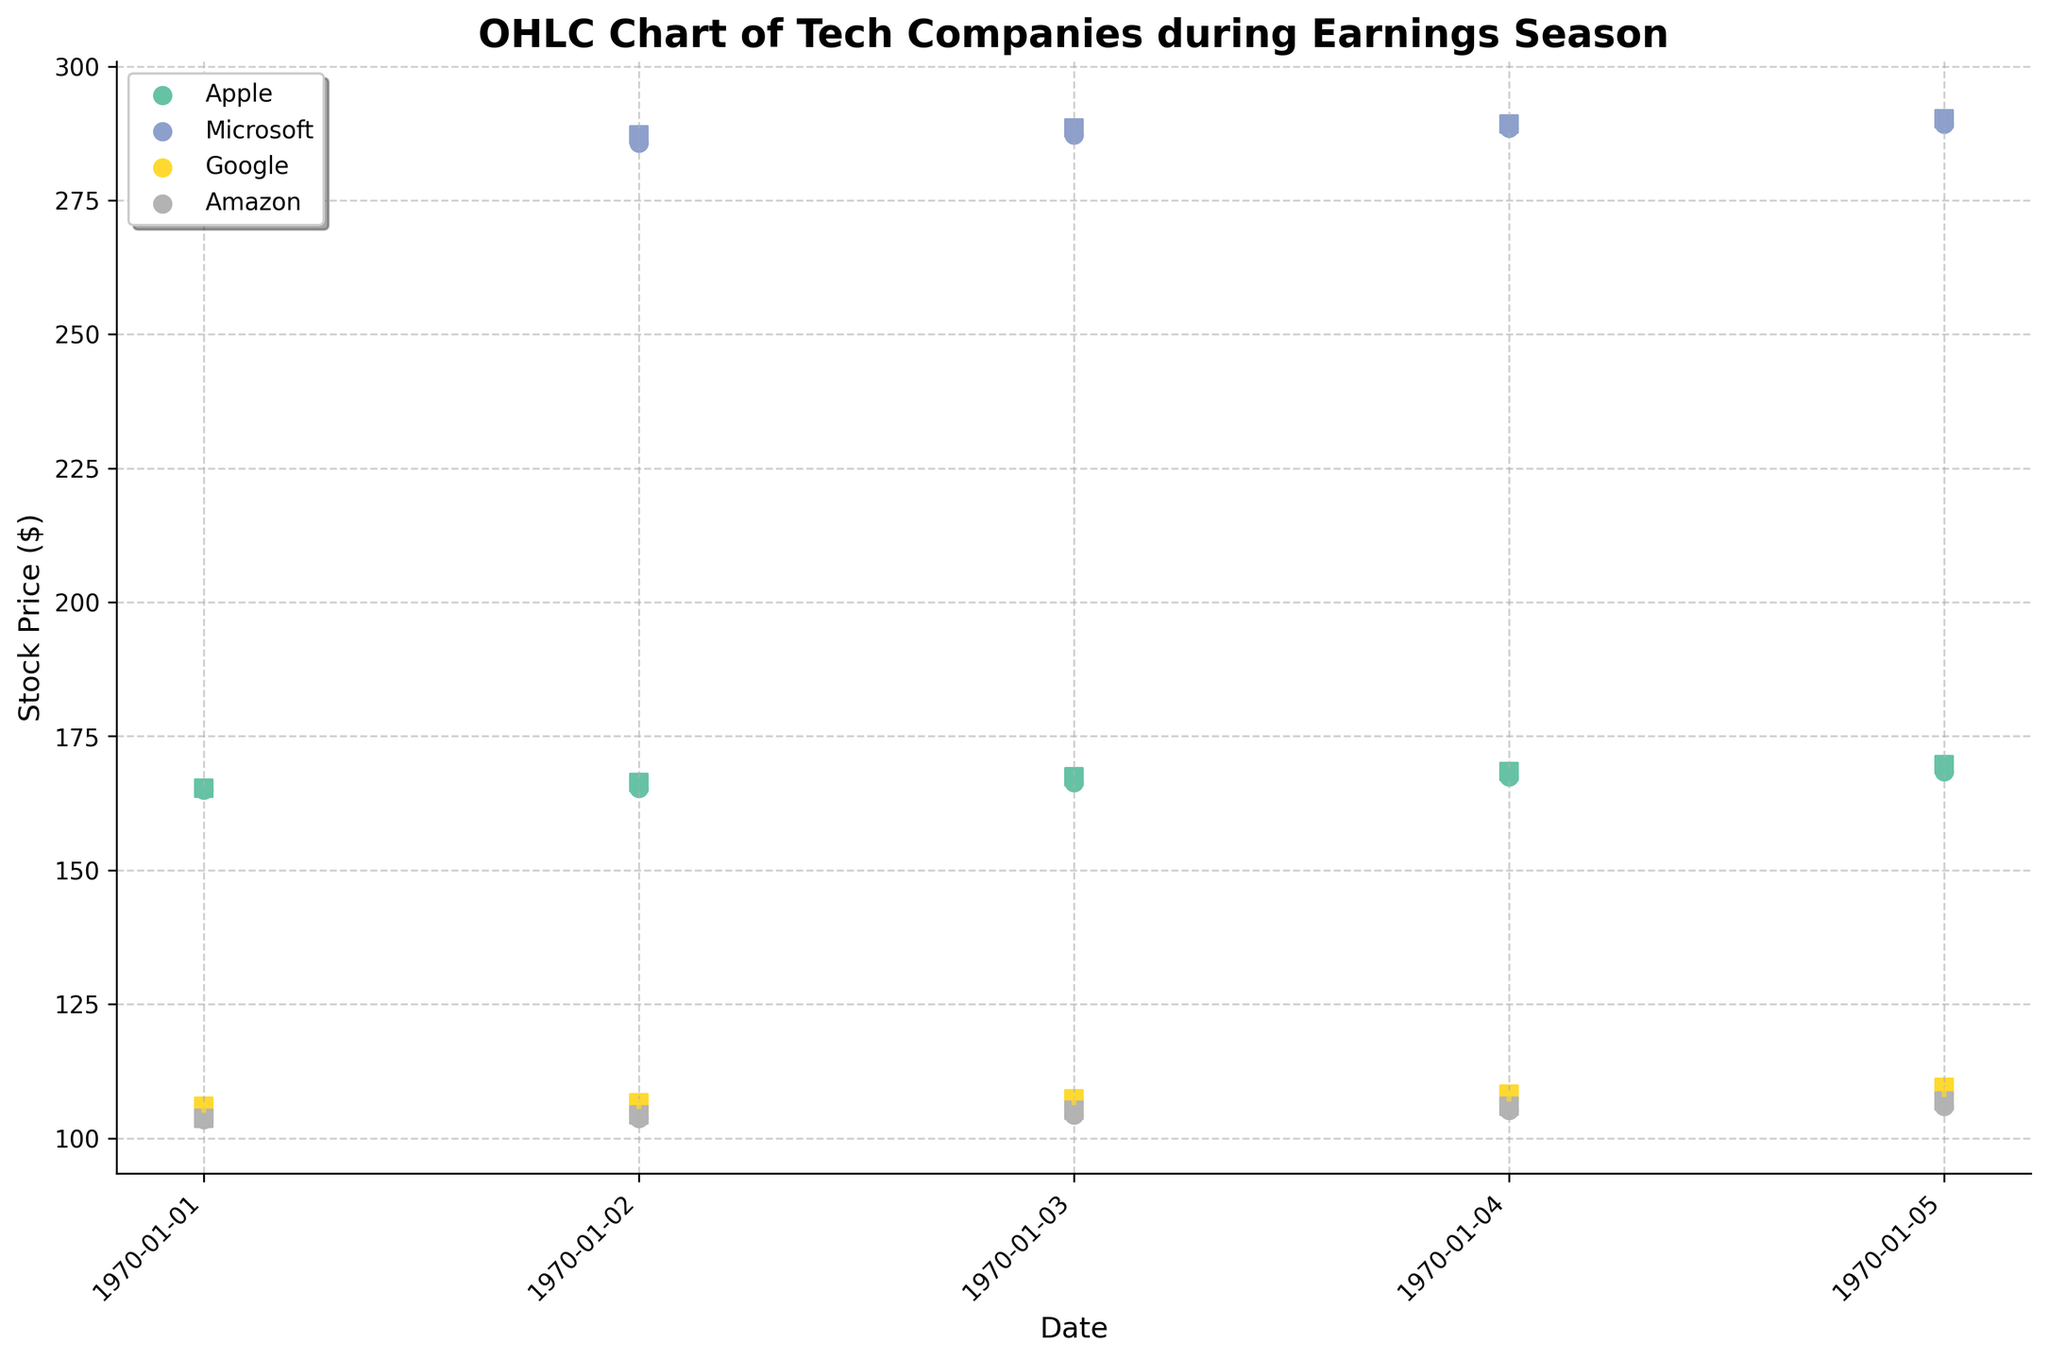What is the title of the chart? The title of the chart is clearly displayed at the top.
Answer: OHLC Chart of Tech Companies during Earnings Season Which company had the highest close price on April 28, 2023? Look at the data points for April 28, 2023, and compare the close prices for each company.
Answer: Microsoft How many companies are represented in the chart? Count the different labels or markers found in the chart legend.
Answer: Four Which company showed the greatest increase in stock price from April 24 to April 28? Calculate the difference between the open price on April 24 and the close price on April 28 for each company, then find which company has the highest value.
Answer: Apple What is the range of Apple's stock price on April 26, 2023? Identify the high and low values for Apple on April 26, 2023, then subtract the low from the high.
Answer: 1.95 Which company's stock has the lowest low on April 25, 2023? Compare the low prices of all companies on April 25, 2023.
Answer: Amazon Did Google’s stock price close higher on April 26, 2023, compared to April 24, 2023? Compare the close prices for Google on April 24 and April 26, 2023.
Answer: Yes Which company's stock price experienced the smallest change in range from April 24, 2023, to April 28, 2023? Calculate the range (high - low) for each day for each company, then find the company with the smallest range difference over the days.
Answer: Microsoft What visual elements are used to represent stock prices on the chart? Identify the markers, lines, and colors in the chart.
Answer: Vertical lines for high and low, circles for open, squares for close On which date did Amazon’s stock price close the highest? Compare the close prices for Amazon on each date.
Answer: April 28, 2023 